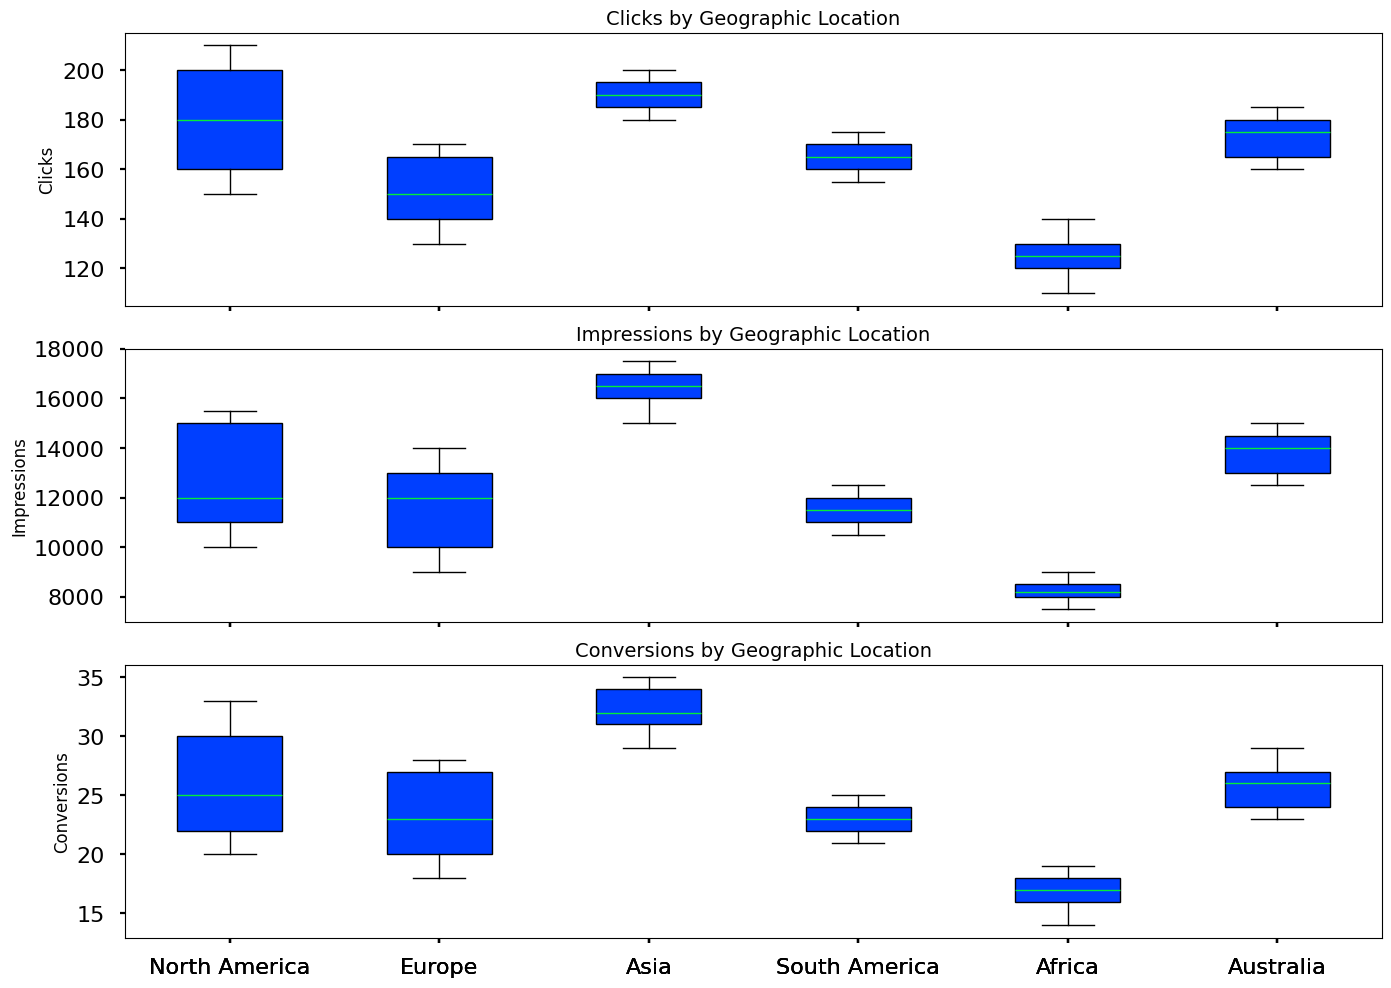How does the median number of clicks in North America compare to that in Europe? Identify the median value in the box plot for each region: North America and Europe. Locate the boxplot line (median) and compare these values.
Answer: The median number of clicks is slightly higher in North America Which geographic location has the highest median number of conversions? Identify the median line (the middle line in each box plot) in the Conversions plot. Compare these median values across all geographic locations to determine which one is the highest.
Answer: Asia What is the range of impressions in South America? Look at the box for South America in the Impressions plot. The range is defined by the difference between the top and bottom of the box plot whiskers.
Answer: Between 10,500 and 12,500 Which two geographic locations have the widest range of clicks? Find the length of the whiskers (the lines extending above and below the boxes) in the Clicks plot for all regions. Determine which two locations show the largest difference between their highest and lowest points.
Answer: North America and Asia How does the variability in conversions for Africa compare to that of Australia? Assess the length of the boxes (Interquartile Range, IQR) and whiskers in the Conversions plot for Africa and Australia. Longer boxes and whiskers indicate higher variability.
Answer: Africa has lower variability than Australia What can you say about the consistency of impressions in Europe versus Africa? Observe the length of the boxes (IQR) and whiskers in the Impressions plot for both Europe and Africa. Shorter boxes and whiskers reflect higher consistency.
Answer: Europe is less consistent than Africa Which geographic location has the smallest range for conversions and what is that range? Identify the geographic location with the smallest distance between the top and bottom whiskers in the Conversions plot. Measure this range.
Answer: Africa, between 14 and 19 What location has the highest median impressions? Compare the highest points on the median lines (middle line in each box) for all geographic locations in the Impressions plot. Locate the highest point.
Answer: Asia Compare the distribution of clicks across North America and Africa. What can you deduce? Look at the spread and IQR width of the Clicks box plot for North America and Africa. A wider box and longer whiskers indicate a wider distribution and vice versa.
Answer: North America has a wider distribution, indicating more variability in clicks than Africa What is the median number of conversions in South America, and how does it compare with that of Asia? Identify the median value (the middle line in each box) for conversion rates in both South America and Asia. Compare these values to see which is higher.
Answer: South America's median is lower than Asia's 